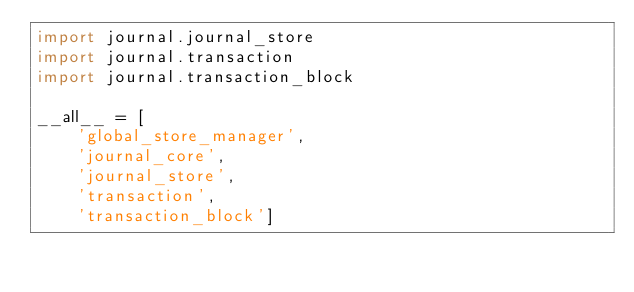<code> <loc_0><loc_0><loc_500><loc_500><_Python_>import journal.journal_store
import journal.transaction
import journal.transaction_block

__all__ = [
    'global_store_manager',
    'journal_core',
    'journal_store',
    'transaction',
    'transaction_block']
</code> 